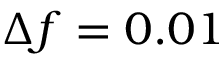<formula> <loc_0><loc_0><loc_500><loc_500>\Delta f = 0 . 0 1</formula> 